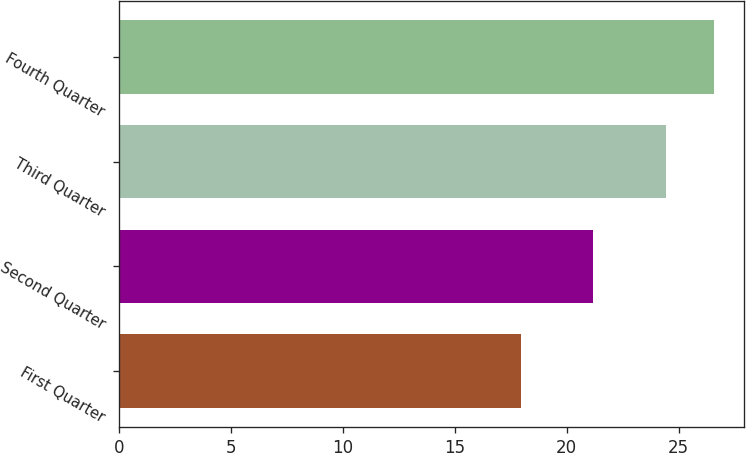Convert chart. <chart><loc_0><loc_0><loc_500><loc_500><bar_chart><fcel>First Quarter<fcel>Second Quarter<fcel>Third Quarter<fcel>Fourth Quarter<nl><fcel>17.94<fcel>21.15<fcel>24.45<fcel>26.56<nl></chart> 